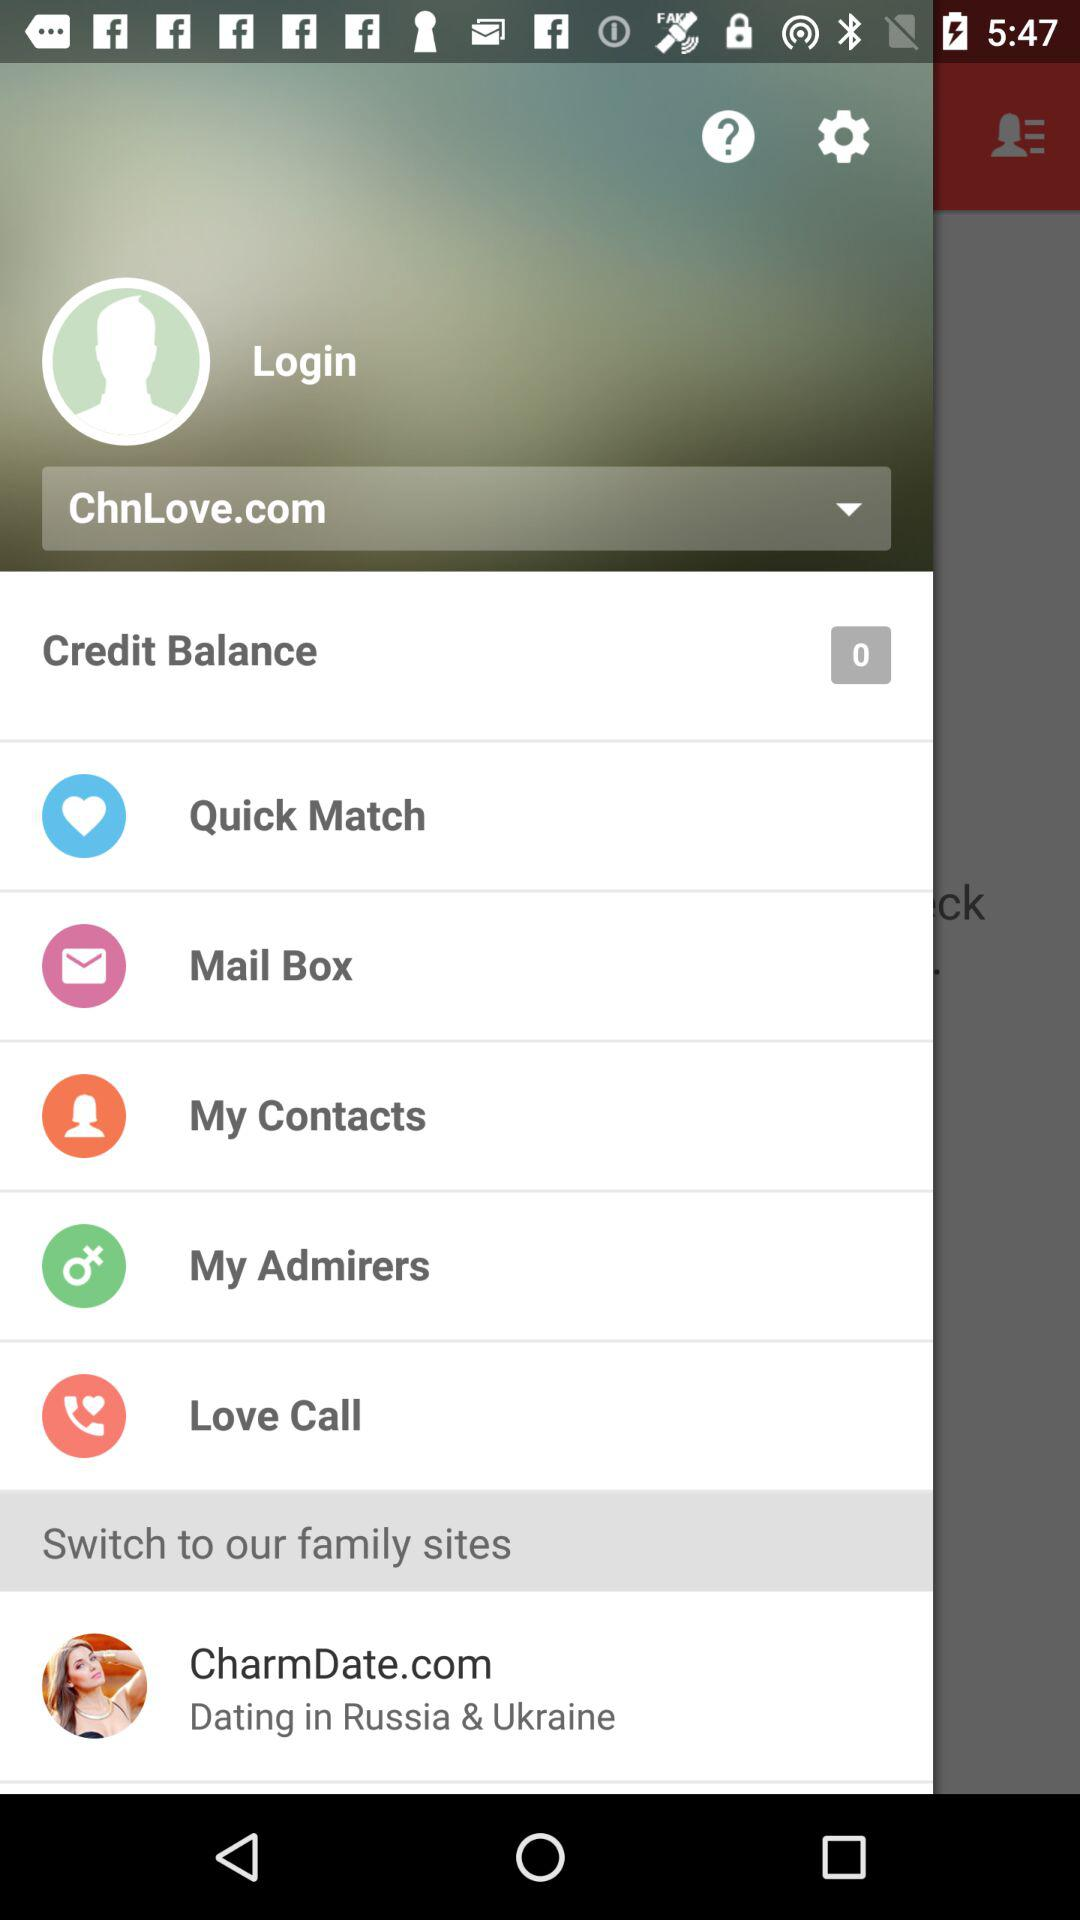What is the site name? The site names are ChnLove.com and CharmDate.com. 